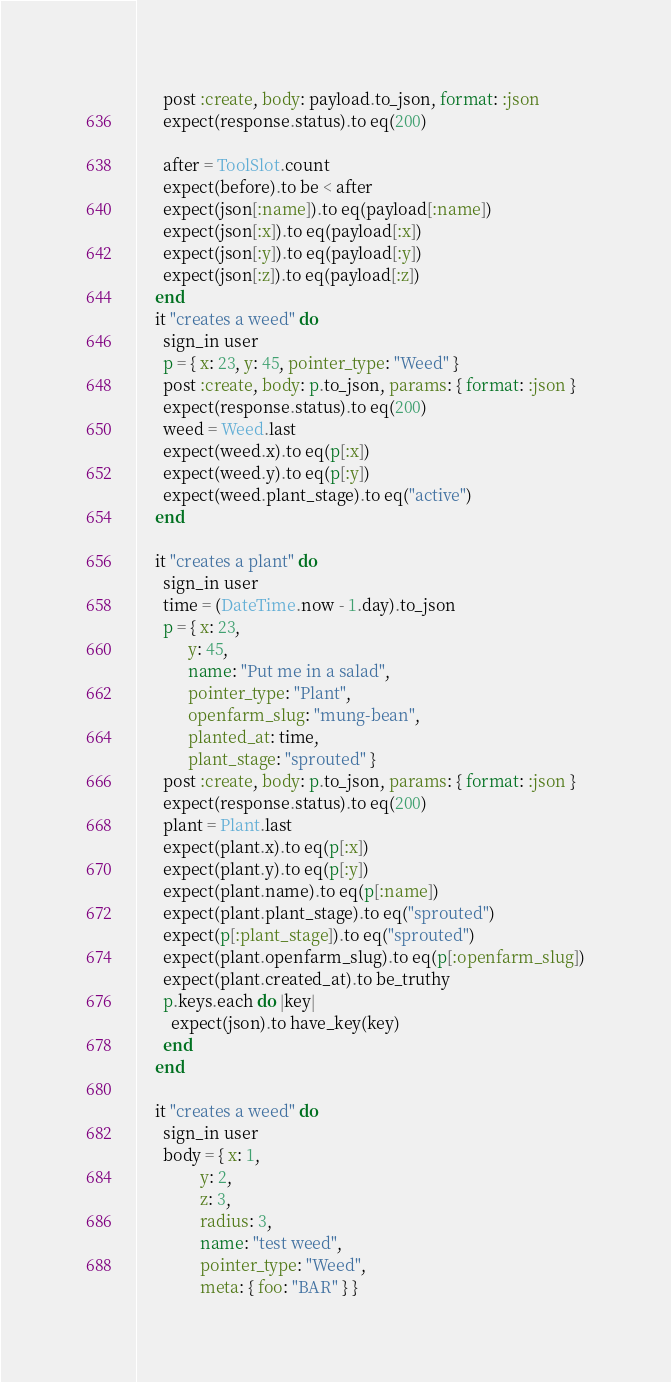<code> <loc_0><loc_0><loc_500><loc_500><_Ruby_>      post :create, body: payload.to_json, format: :json
      expect(response.status).to eq(200)

      after = ToolSlot.count
      expect(before).to be < after
      expect(json[:name]).to eq(payload[:name])
      expect(json[:x]).to eq(payload[:x])
      expect(json[:y]).to eq(payload[:y])
      expect(json[:z]).to eq(payload[:z])
    end
    it "creates a weed" do
      sign_in user
      p = { x: 23, y: 45, pointer_type: "Weed" }
      post :create, body: p.to_json, params: { format: :json }
      expect(response.status).to eq(200)
      weed = Weed.last
      expect(weed.x).to eq(p[:x])
      expect(weed.y).to eq(p[:y])
      expect(weed.plant_stage).to eq("active")
    end

    it "creates a plant" do
      sign_in user
      time = (DateTime.now - 1.day).to_json
      p = { x: 23,
            y: 45,
            name: "Put me in a salad",
            pointer_type: "Plant",
            openfarm_slug: "mung-bean",
            planted_at: time,
            plant_stage: "sprouted" }
      post :create, body: p.to_json, params: { format: :json }
      expect(response.status).to eq(200)
      plant = Plant.last
      expect(plant.x).to eq(p[:x])
      expect(plant.y).to eq(p[:y])
      expect(plant.name).to eq(p[:name])
      expect(plant.plant_stage).to eq("sprouted")
      expect(p[:plant_stage]).to eq("sprouted")
      expect(plant.openfarm_slug).to eq(p[:openfarm_slug])
      expect(plant.created_at).to be_truthy
      p.keys.each do |key|
        expect(json).to have_key(key)
      end
    end

    it "creates a weed" do
      sign_in user
      body = { x: 1,
               y: 2,
               z: 3,
               radius: 3,
               name: "test weed",
               pointer_type: "Weed",
               meta: { foo: "BAR" } }</code> 